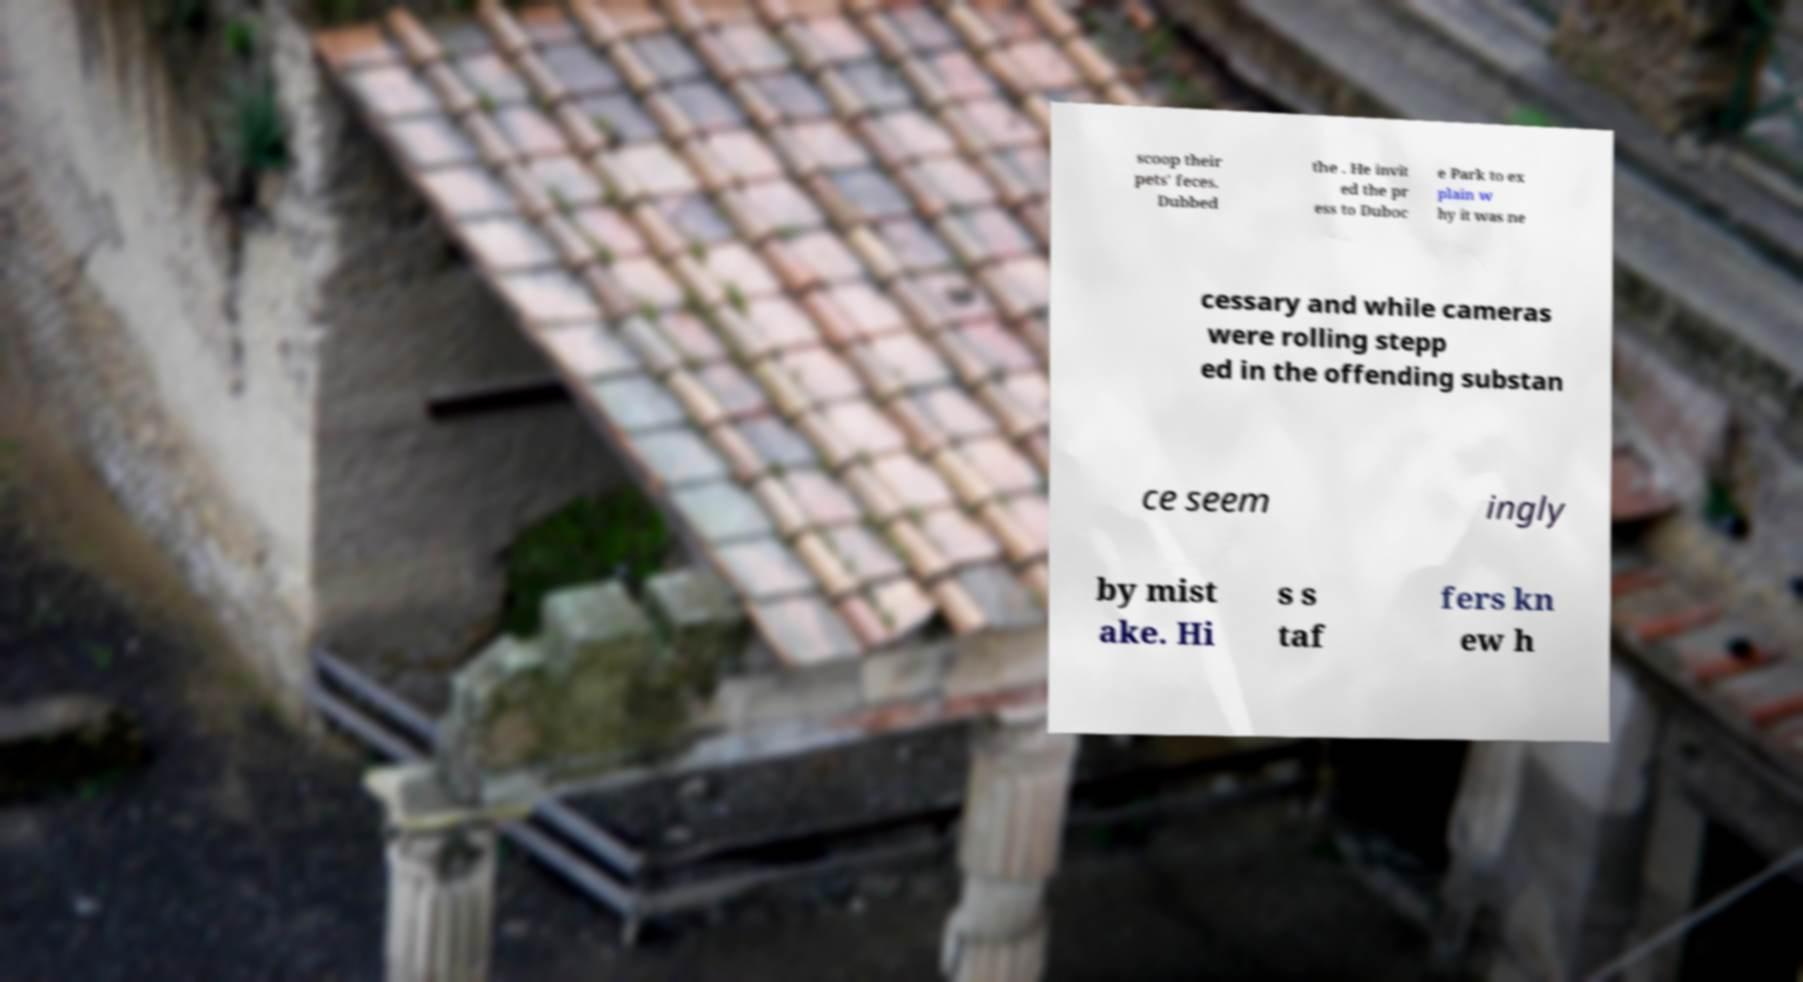Could you assist in decoding the text presented in this image and type it out clearly? scoop their pets' feces. Dubbed the . He invit ed the pr ess to Duboc e Park to ex plain w hy it was ne cessary and while cameras were rolling stepp ed in the offending substan ce seem ingly by mist ake. Hi s s taf fers kn ew h 